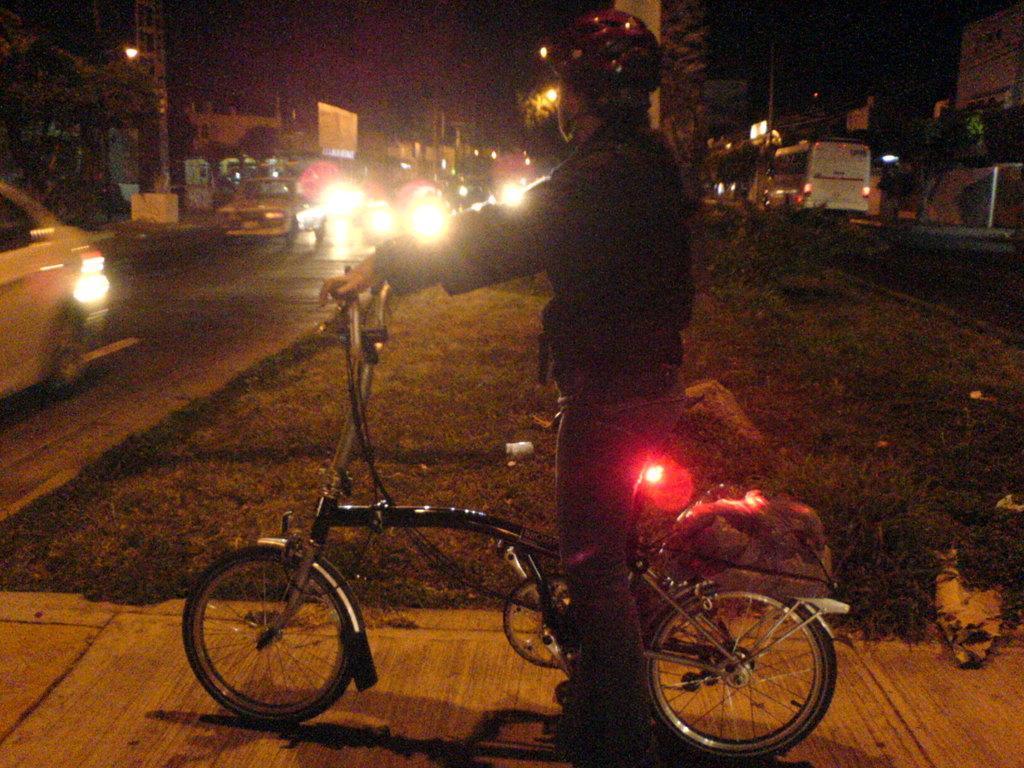How would you summarize this image in a sentence or two? Here in this picture we can see a person sitting on a bicycle present on the ground over there and we can see a light on the bicycle present over there and beside him we can see the ground is covered with grass over there and we can see cars, vans and buses present on the road over there and we can see trees present over there and we can also see light posts and buildings present over there. 